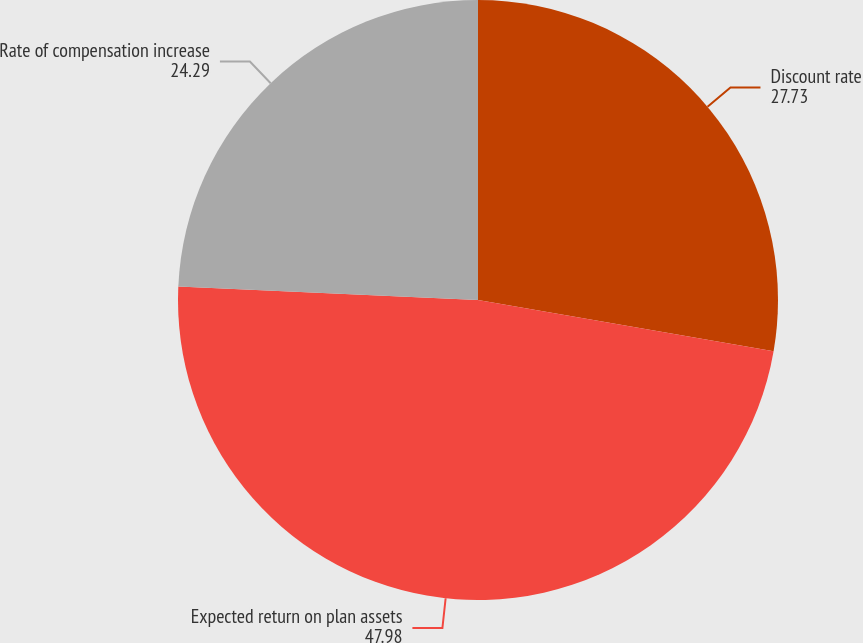Convert chart to OTSL. <chart><loc_0><loc_0><loc_500><loc_500><pie_chart><fcel>Discount rate<fcel>Expected return on plan assets<fcel>Rate of compensation increase<nl><fcel>27.73%<fcel>47.98%<fcel>24.29%<nl></chart> 